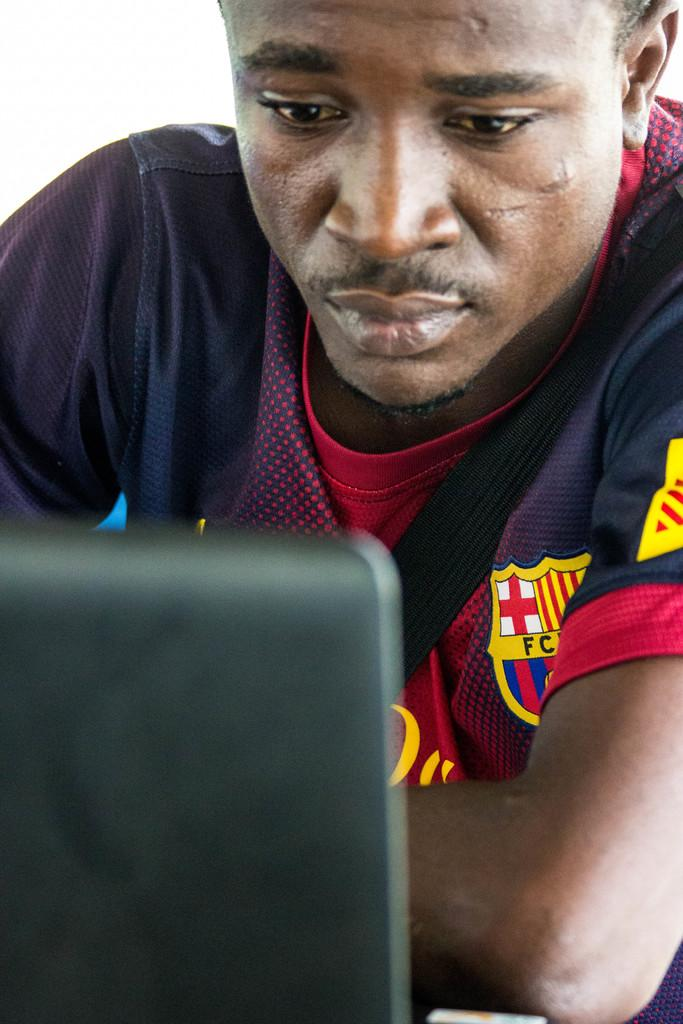Who or what is the main subject in the image? There is a person in the image. What is the person doing in the image? The person is sitting. What object is the person interacting with in the image? The person is in front of a laptop. How many snails can be seen crawling on the laptop in the image? There are no snails present in the image, and therefore no snails can be seen crawling on the laptop. 